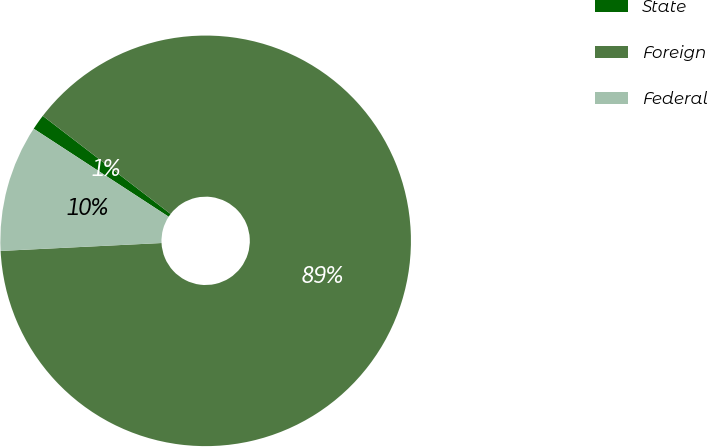Convert chart to OTSL. <chart><loc_0><loc_0><loc_500><loc_500><pie_chart><fcel>State<fcel>Foreign<fcel>Federal<nl><fcel>1.22%<fcel>88.8%<fcel>9.98%<nl></chart> 